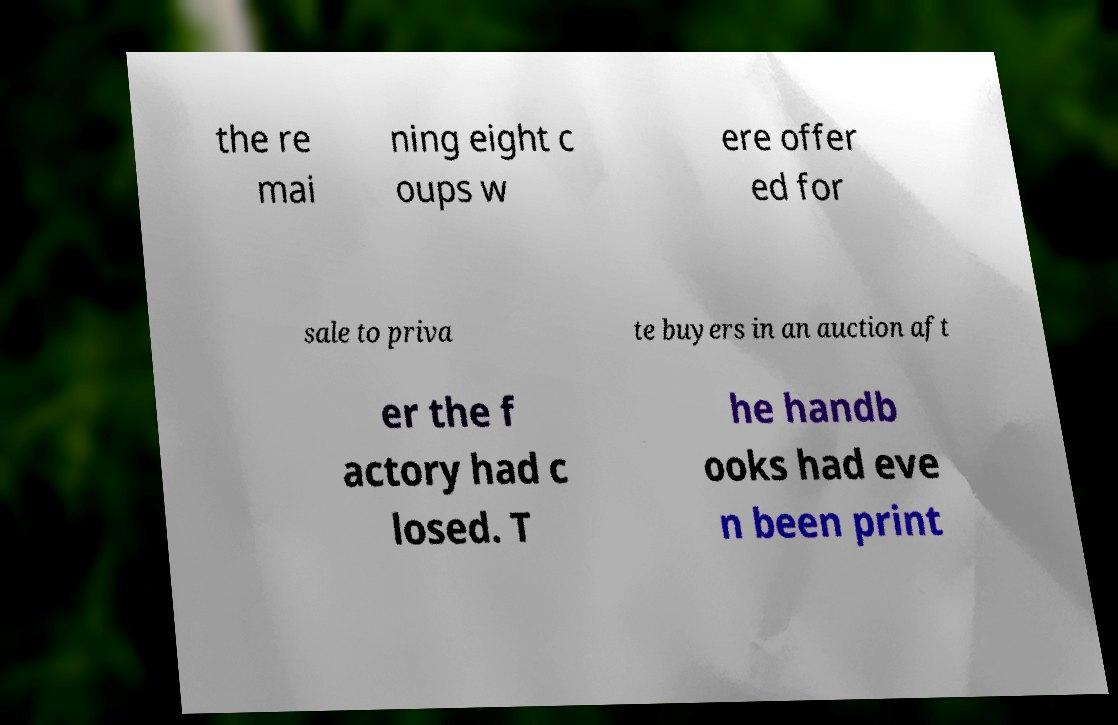Can you accurately transcribe the text from the provided image for me? the re mai ning eight c oups w ere offer ed for sale to priva te buyers in an auction aft er the f actory had c losed. T he handb ooks had eve n been print 